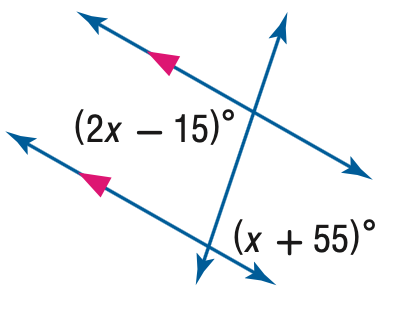Question: Find the value of the variable x in the figure.
Choices:
A. 46.7
B. 60
C. 70
D. 80
Answer with the letter. Answer: C 